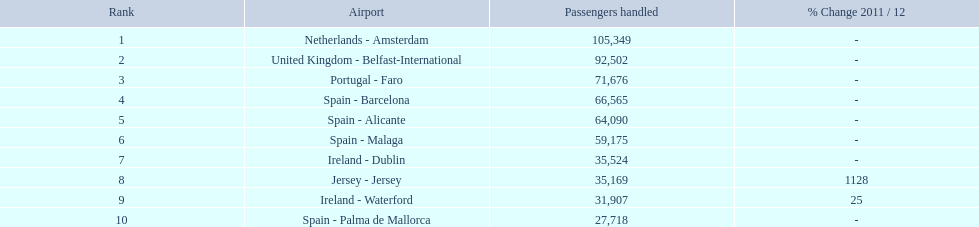What are the airports? Netherlands - Amsterdam, United Kingdom - Belfast-International, Portugal - Faro, Spain - Barcelona, Spain - Alicante, Spain - Malaga, Ireland - Dublin, Jersey - Jersey, Ireland - Waterford, Spain - Palma de Mallorca. Of these which has the least amount of passengers? Spain - Palma de Mallorca. 